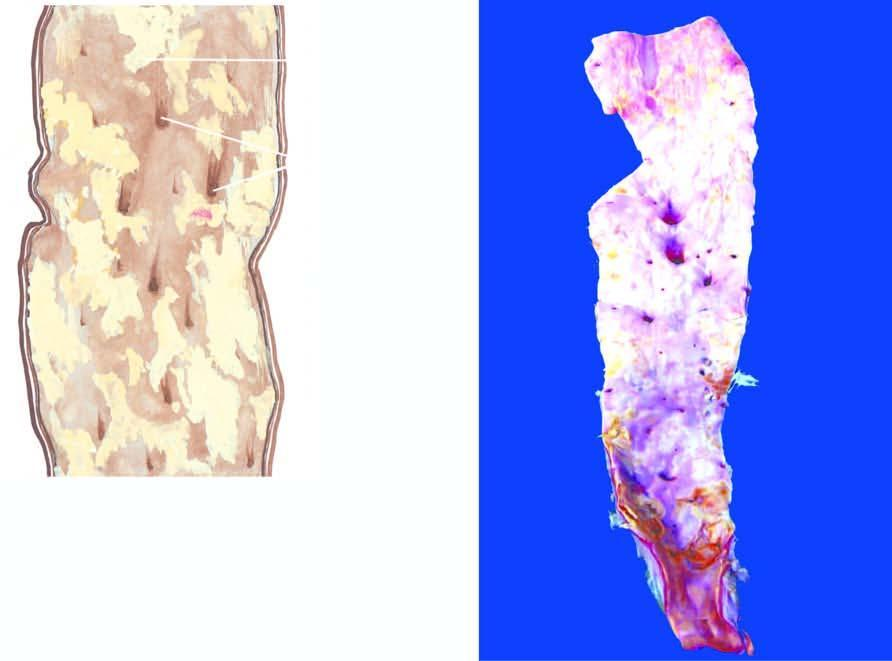what does the opened up inner surface of the abdominal aorta show?
Answer the question using a single word or phrase. A variety of atheromatous lesions 